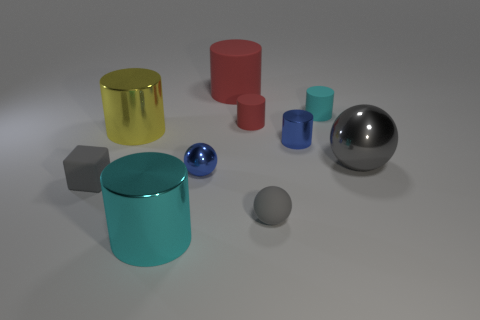How many objects are big blue metallic objects or red things? In the image, there are two objects that fit the description - one is a large blue, metallic cylinder, and the other is a red cylinder. No other objects meet the criteria of being both large and blue and metallic or being red. 